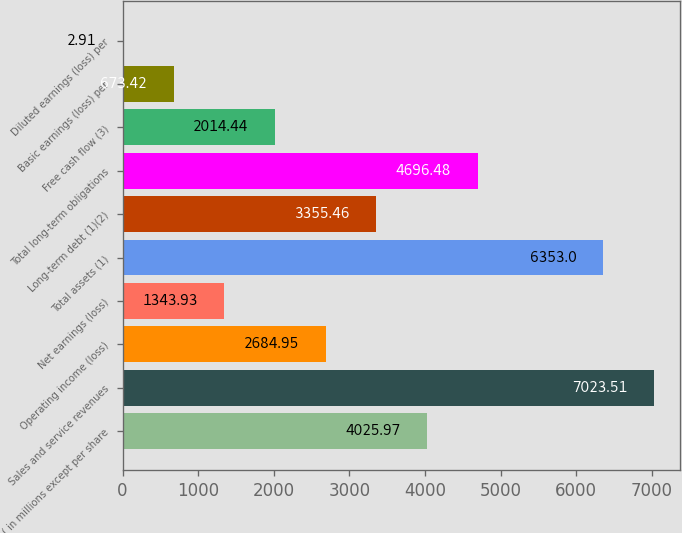Convert chart to OTSL. <chart><loc_0><loc_0><loc_500><loc_500><bar_chart><fcel>( in millions except per share<fcel>Sales and service revenues<fcel>Operating income (loss)<fcel>Net earnings (loss)<fcel>Total assets (1)<fcel>Long-term debt (1)(2)<fcel>Total long-term obligations<fcel>Free cash flow (3)<fcel>Basic earnings (loss) per<fcel>Diluted earnings (loss) per<nl><fcel>4025.97<fcel>7023.51<fcel>2684.95<fcel>1343.93<fcel>6353<fcel>3355.46<fcel>4696.48<fcel>2014.44<fcel>673.42<fcel>2.91<nl></chart> 